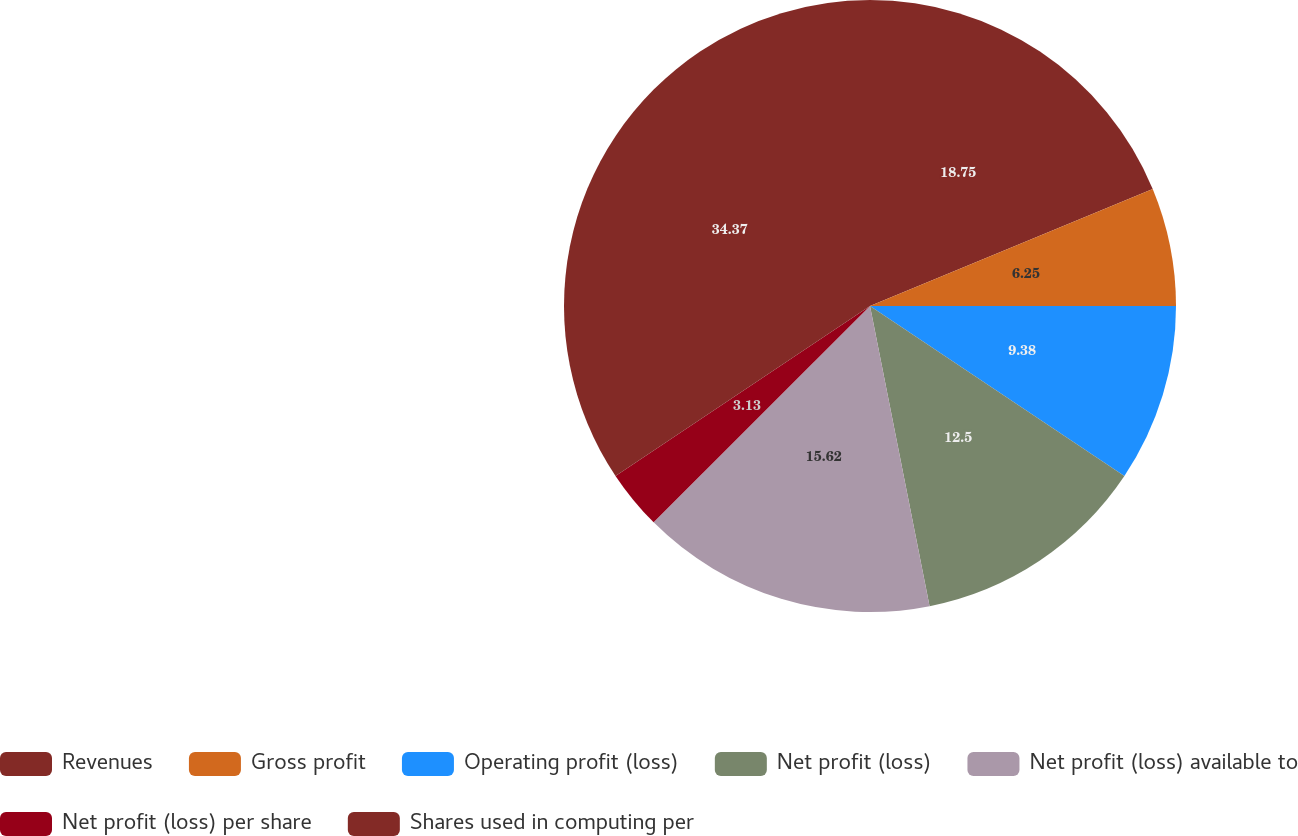Convert chart to OTSL. <chart><loc_0><loc_0><loc_500><loc_500><pie_chart><fcel>Revenues<fcel>Gross profit<fcel>Operating profit (loss)<fcel>Net profit (loss)<fcel>Net profit (loss) available to<fcel>Net profit (loss) per share<fcel>Shares used in computing per<nl><fcel>18.75%<fcel>6.25%<fcel>9.38%<fcel>12.5%<fcel>15.62%<fcel>3.13%<fcel>34.37%<nl></chart> 